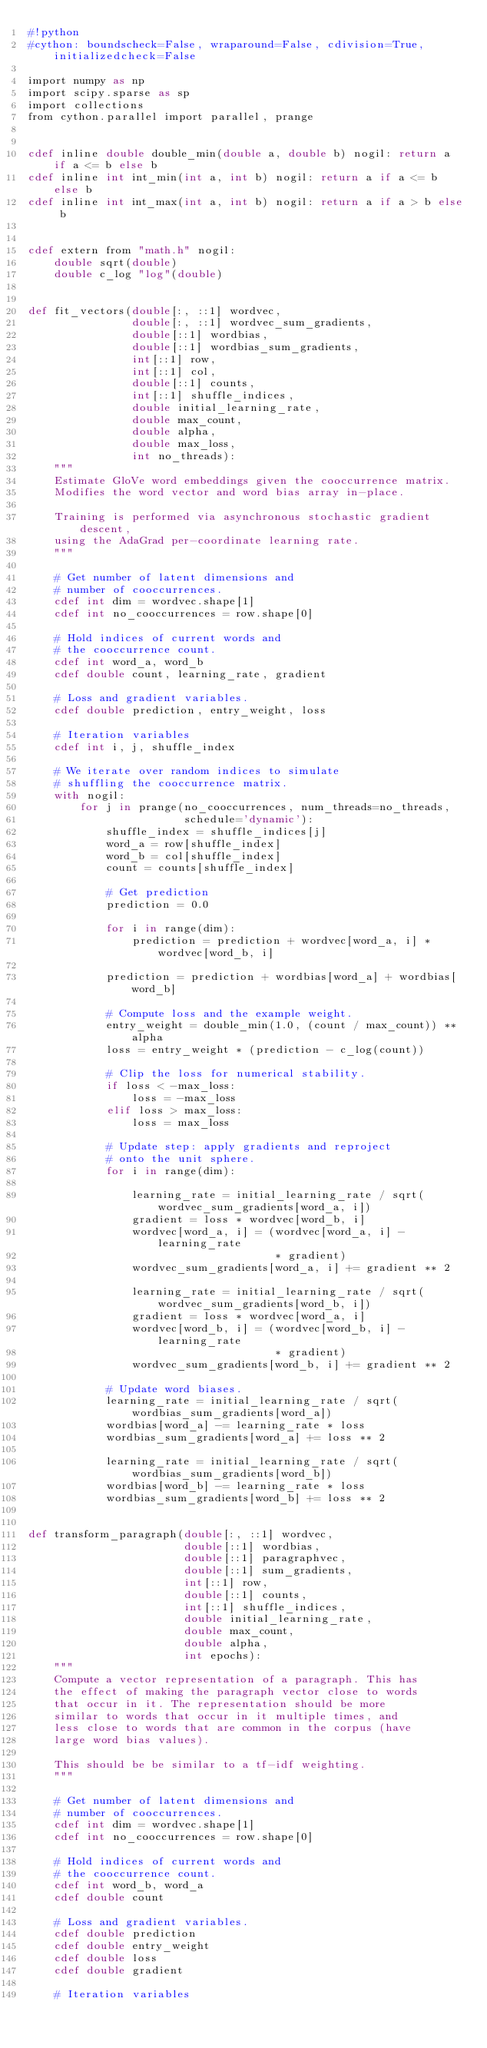<code> <loc_0><loc_0><loc_500><loc_500><_Cython_>#!python
#cython: boundscheck=False, wraparound=False, cdivision=True, initializedcheck=False

import numpy as np
import scipy.sparse as sp
import collections
from cython.parallel import parallel, prange


cdef inline double double_min(double a, double b) nogil: return a if a <= b else b
cdef inline int int_min(int a, int b) nogil: return a if a <= b else b
cdef inline int int_max(int a, int b) nogil: return a if a > b else b


cdef extern from "math.h" nogil:
    double sqrt(double)
    double c_log "log"(double)


def fit_vectors(double[:, ::1] wordvec,
                double[:, ::1] wordvec_sum_gradients,
                double[::1] wordbias,
                double[::1] wordbias_sum_gradients,
                int[::1] row,
                int[::1] col,
                double[::1] counts,
                int[::1] shuffle_indices,
                double initial_learning_rate,
                double max_count,
                double alpha,
                double max_loss,
                int no_threads):
    """
    Estimate GloVe word embeddings given the cooccurrence matrix.
    Modifies the word vector and word bias array in-place.

    Training is performed via asynchronous stochastic gradient descent,
    using the AdaGrad per-coordinate learning rate.
    """

    # Get number of latent dimensions and
    # number of cooccurrences.
    cdef int dim = wordvec.shape[1]
    cdef int no_cooccurrences = row.shape[0]

    # Hold indices of current words and
    # the cooccurrence count.
    cdef int word_a, word_b
    cdef double count, learning_rate, gradient

    # Loss and gradient variables.
    cdef double prediction, entry_weight, loss

    # Iteration variables
    cdef int i, j, shuffle_index

    # We iterate over random indices to simulate
    # shuffling the cooccurrence matrix.
    with nogil:
        for j in prange(no_cooccurrences, num_threads=no_threads,
                        schedule='dynamic'):
            shuffle_index = shuffle_indices[j]
            word_a = row[shuffle_index]
            word_b = col[shuffle_index]
            count = counts[shuffle_index]

            # Get prediction
            prediction = 0.0

            for i in range(dim):
                prediction = prediction + wordvec[word_a, i] * wordvec[word_b, i]

            prediction = prediction + wordbias[word_a] + wordbias[word_b]

            # Compute loss and the example weight.
            entry_weight = double_min(1.0, (count / max_count)) ** alpha
            loss = entry_weight * (prediction - c_log(count))

            # Clip the loss for numerical stability.
            if loss < -max_loss:
                loss = -max_loss
            elif loss > max_loss:
                loss = max_loss

            # Update step: apply gradients and reproject
            # onto the unit sphere.
            for i in range(dim):

                learning_rate = initial_learning_rate / sqrt(wordvec_sum_gradients[word_a, i])
                gradient = loss * wordvec[word_b, i]
                wordvec[word_a, i] = (wordvec[word_a, i] - learning_rate
                                      * gradient)
                wordvec_sum_gradients[word_a, i] += gradient ** 2

                learning_rate = initial_learning_rate / sqrt(wordvec_sum_gradients[word_b, i])
                gradient = loss * wordvec[word_a, i]
                wordvec[word_b, i] = (wordvec[word_b, i] - learning_rate
                                      * gradient)
                wordvec_sum_gradients[word_b, i] += gradient ** 2

            # Update word biases.
            learning_rate = initial_learning_rate / sqrt(wordbias_sum_gradients[word_a])
            wordbias[word_a] -= learning_rate * loss
            wordbias_sum_gradients[word_a] += loss ** 2

            learning_rate = initial_learning_rate / sqrt(wordbias_sum_gradients[word_b])
            wordbias[word_b] -= learning_rate * loss
            wordbias_sum_gradients[word_b] += loss ** 2


def transform_paragraph(double[:, ::1] wordvec,
                        double[::1] wordbias,
                        double[::1] paragraphvec,
                        double[::1] sum_gradients,
                        int[::1] row,
                        double[::1] counts,
                        int[::1] shuffle_indices,
                        double initial_learning_rate,
                        double max_count,
                        double alpha,
                        int epochs):
    """
    Compute a vector representation of a paragraph. This has
    the effect of making the paragraph vector close to words
    that occur in it. The representation should be more
    similar to words that occur in it multiple times, and
    less close to words that are common in the corpus (have
    large word bias values).

    This should be be similar to a tf-idf weighting.
    """

    # Get number of latent dimensions and
    # number of cooccurrences.
    cdef int dim = wordvec.shape[1]
    cdef int no_cooccurrences = row.shape[0]

    # Hold indices of current words and
    # the cooccurrence count.
    cdef int word_b, word_a
    cdef double count

    # Loss and gradient variables.
    cdef double prediction
    cdef double entry_weight
    cdef double loss
    cdef double gradient

    # Iteration variables</code> 